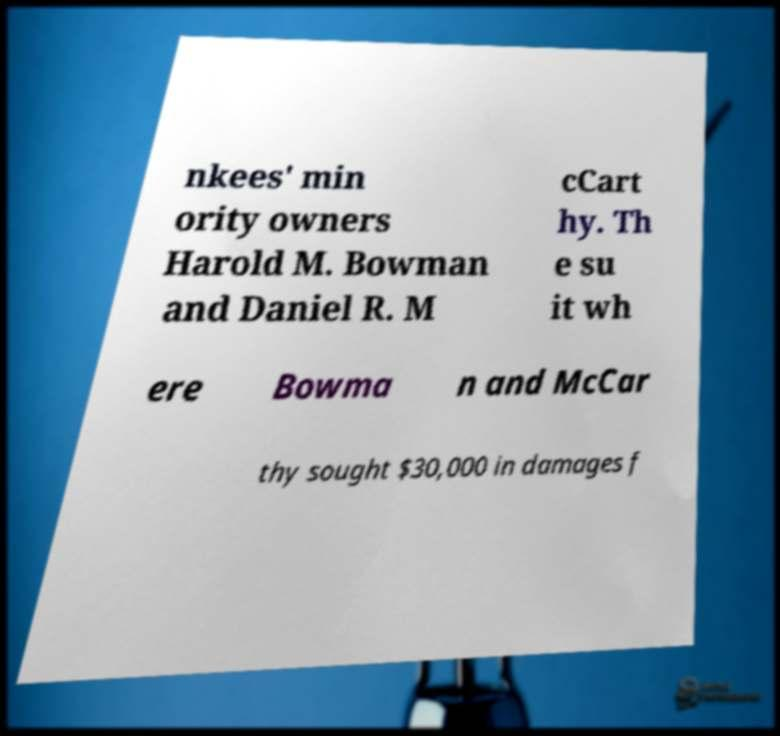Could you extract and type out the text from this image? nkees' min ority owners Harold M. Bowman and Daniel R. M cCart hy. Th e su it wh ere Bowma n and McCar thy sought $30,000 in damages f 